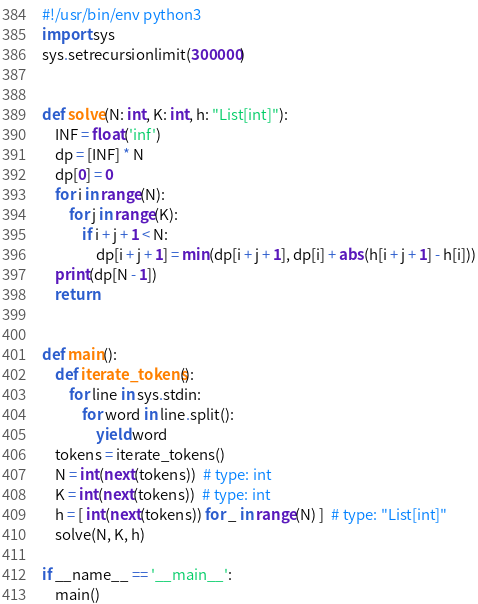Convert code to text. <code><loc_0><loc_0><loc_500><loc_500><_Python_>#!/usr/bin/env python3
import sys
sys.setrecursionlimit(300000)
 
 
def solve(N: int, K: int, h: "List[int]"):
    INF = float('inf')
    dp = [INF] * N
    dp[0] = 0
    for i in range(N):
        for j in range(K):
            if i + j + 1 < N:
                dp[i + j + 1] = min(dp[i + j + 1], dp[i] + abs(h[i + j + 1] - h[i]))
    print(dp[N - 1])
    return
 
 
def main():
    def iterate_tokens():
        for line in sys.stdin:
            for word in line.split():
                yield word
    tokens = iterate_tokens()
    N = int(next(tokens))  # type: int
    K = int(next(tokens))  # type: int
    h = [ int(next(tokens)) for _ in range(N) ]  # type: "List[int]"
    solve(N, K, h)
 
if __name__ == '__main__':
    main()</code> 